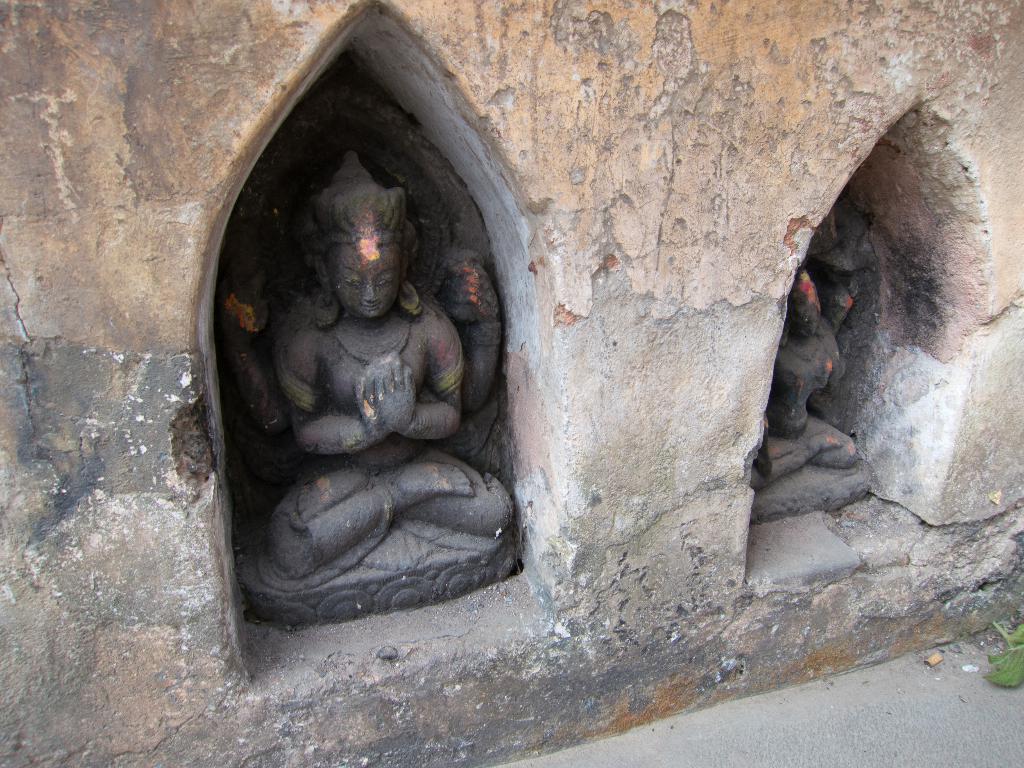Describe this image in one or two sentences. In this image two idols are inside the wall. Right bottom there is a floor having a leaf on it. 